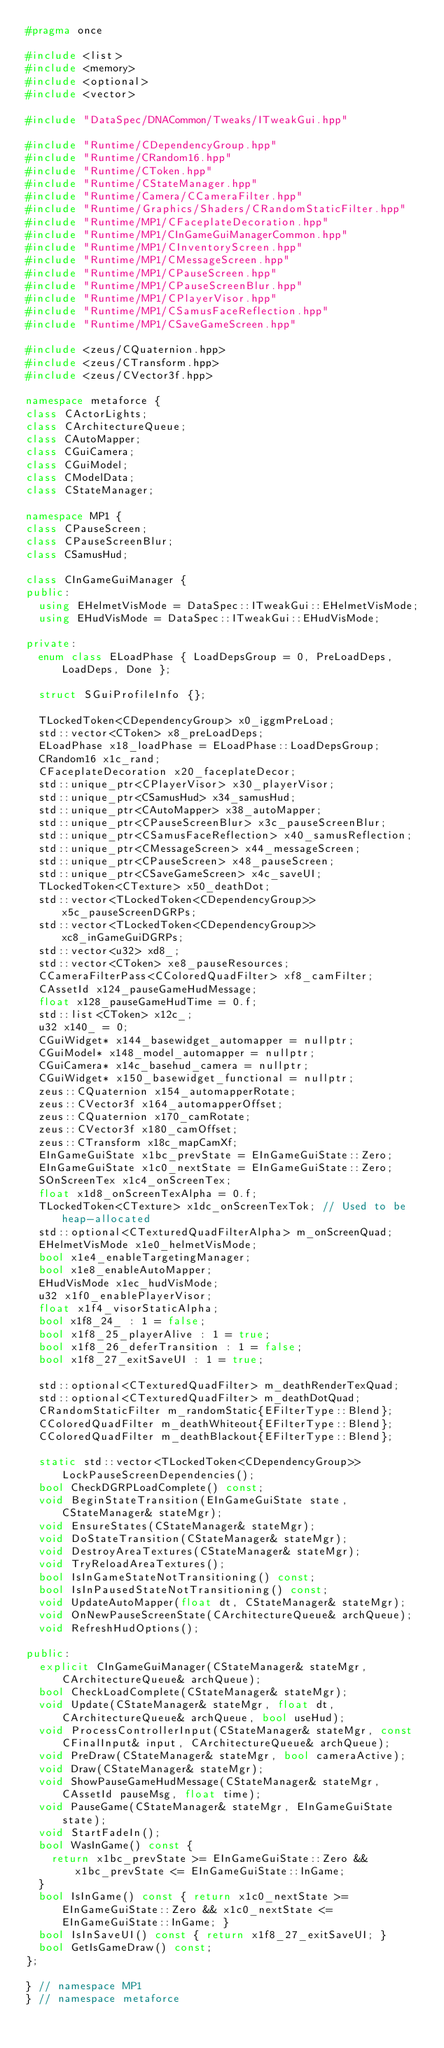Convert code to text. <code><loc_0><loc_0><loc_500><loc_500><_C++_>#pragma once

#include <list>
#include <memory>
#include <optional>
#include <vector>

#include "DataSpec/DNACommon/Tweaks/ITweakGui.hpp"

#include "Runtime/CDependencyGroup.hpp"
#include "Runtime/CRandom16.hpp"
#include "Runtime/CToken.hpp"
#include "Runtime/CStateManager.hpp"
#include "Runtime/Camera/CCameraFilter.hpp"
#include "Runtime/Graphics/Shaders/CRandomStaticFilter.hpp"
#include "Runtime/MP1/CFaceplateDecoration.hpp"
#include "Runtime/MP1/CInGameGuiManagerCommon.hpp"
#include "Runtime/MP1/CInventoryScreen.hpp"
#include "Runtime/MP1/CMessageScreen.hpp"
#include "Runtime/MP1/CPauseScreen.hpp"
#include "Runtime/MP1/CPauseScreenBlur.hpp"
#include "Runtime/MP1/CPlayerVisor.hpp"
#include "Runtime/MP1/CSamusFaceReflection.hpp"
#include "Runtime/MP1/CSaveGameScreen.hpp"

#include <zeus/CQuaternion.hpp>
#include <zeus/CTransform.hpp>
#include <zeus/CVector3f.hpp>

namespace metaforce {
class CActorLights;
class CArchitectureQueue;
class CAutoMapper;
class CGuiCamera;
class CGuiModel;
class CModelData;
class CStateManager;

namespace MP1 {
class CPauseScreen;
class CPauseScreenBlur;
class CSamusHud;

class CInGameGuiManager {
public:
  using EHelmetVisMode = DataSpec::ITweakGui::EHelmetVisMode;
  using EHudVisMode = DataSpec::ITweakGui::EHudVisMode;

private:
  enum class ELoadPhase { LoadDepsGroup = 0, PreLoadDeps, LoadDeps, Done };

  struct SGuiProfileInfo {};

  TLockedToken<CDependencyGroup> x0_iggmPreLoad;
  std::vector<CToken> x8_preLoadDeps;
  ELoadPhase x18_loadPhase = ELoadPhase::LoadDepsGroup;
  CRandom16 x1c_rand;
  CFaceplateDecoration x20_faceplateDecor;
  std::unique_ptr<CPlayerVisor> x30_playerVisor;
  std::unique_ptr<CSamusHud> x34_samusHud;
  std::unique_ptr<CAutoMapper> x38_autoMapper;
  std::unique_ptr<CPauseScreenBlur> x3c_pauseScreenBlur;
  std::unique_ptr<CSamusFaceReflection> x40_samusReflection;
  std::unique_ptr<CMessageScreen> x44_messageScreen;
  std::unique_ptr<CPauseScreen> x48_pauseScreen;
  std::unique_ptr<CSaveGameScreen> x4c_saveUI;
  TLockedToken<CTexture> x50_deathDot;
  std::vector<TLockedToken<CDependencyGroup>> x5c_pauseScreenDGRPs;
  std::vector<TLockedToken<CDependencyGroup>> xc8_inGameGuiDGRPs;
  std::vector<u32> xd8_;
  std::vector<CToken> xe8_pauseResources;
  CCameraFilterPass<CColoredQuadFilter> xf8_camFilter;
  CAssetId x124_pauseGameHudMessage;
  float x128_pauseGameHudTime = 0.f;
  std::list<CToken> x12c_;
  u32 x140_ = 0;
  CGuiWidget* x144_basewidget_automapper = nullptr;
  CGuiModel* x148_model_automapper = nullptr;
  CGuiCamera* x14c_basehud_camera = nullptr;
  CGuiWidget* x150_basewidget_functional = nullptr;
  zeus::CQuaternion x154_automapperRotate;
  zeus::CVector3f x164_automapperOffset;
  zeus::CQuaternion x170_camRotate;
  zeus::CVector3f x180_camOffset;
  zeus::CTransform x18c_mapCamXf;
  EInGameGuiState x1bc_prevState = EInGameGuiState::Zero;
  EInGameGuiState x1c0_nextState = EInGameGuiState::Zero;
  SOnScreenTex x1c4_onScreenTex;
  float x1d8_onScreenTexAlpha = 0.f;
  TLockedToken<CTexture> x1dc_onScreenTexTok; // Used to be heap-allocated
  std::optional<CTexturedQuadFilterAlpha> m_onScreenQuad;
  EHelmetVisMode x1e0_helmetVisMode;
  bool x1e4_enableTargetingManager;
  bool x1e8_enableAutoMapper;
  EHudVisMode x1ec_hudVisMode;
  u32 x1f0_enablePlayerVisor;
  float x1f4_visorStaticAlpha;
  bool x1f8_24_ : 1 = false;
  bool x1f8_25_playerAlive : 1 = true;
  bool x1f8_26_deferTransition : 1 = false;
  bool x1f8_27_exitSaveUI : 1 = true;

  std::optional<CTexturedQuadFilter> m_deathRenderTexQuad;
  std::optional<CTexturedQuadFilter> m_deathDotQuad;
  CRandomStaticFilter m_randomStatic{EFilterType::Blend};
  CColoredQuadFilter m_deathWhiteout{EFilterType::Blend};
  CColoredQuadFilter m_deathBlackout{EFilterType::Blend};

  static std::vector<TLockedToken<CDependencyGroup>> LockPauseScreenDependencies();
  bool CheckDGRPLoadComplete() const;
  void BeginStateTransition(EInGameGuiState state, CStateManager& stateMgr);
  void EnsureStates(CStateManager& stateMgr);
  void DoStateTransition(CStateManager& stateMgr);
  void DestroyAreaTextures(CStateManager& stateMgr);
  void TryReloadAreaTextures();
  bool IsInGameStateNotTransitioning() const;
  bool IsInPausedStateNotTransitioning() const;
  void UpdateAutoMapper(float dt, CStateManager& stateMgr);
  void OnNewPauseScreenState(CArchitectureQueue& archQueue);
  void RefreshHudOptions();

public:
  explicit CInGameGuiManager(CStateManager& stateMgr, CArchitectureQueue& archQueue);
  bool CheckLoadComplete(CStateManager& stateMgr);
  void Update(CStateManager& stateMgr, float dt, CArchitectureQueue& archQueue, bool useHud);
  void ProcessControllerInput(CStateManager& stateMgr, const CFinalInput& input, CArchitectureQueue& archQueue);
  void PreDraw(CStateManager& stateMgr, bool cameraActive);
  void Draw(CStateManager& stateMgr);
  void ShowPauseGameHudMessage(CStateManager& stateMgr, CAssetId pauseMsg, float time);
  void PauseGame(CStateManager& stateMgr, EInGameGuiState state);
  void StartFadeIn();
  bool WasInGame() const {
    return x1bc_prevState >= EInGameGuiState::Zero && x1bc_prevState <= EInGameGuiState::InGame;
  }
  bool IsInGame() const { return x1c0_nextState >= EInGameGuiState::Zero && x1c0_nextState <= EInGameGuiState::InGame; }
  bool IsInSaveUI() const { return x1f8_27_exitSaveUI; }
  bool GetIsGameDraw() const;
};

} // namespace MP1
} // namespace metaforce
</code> 